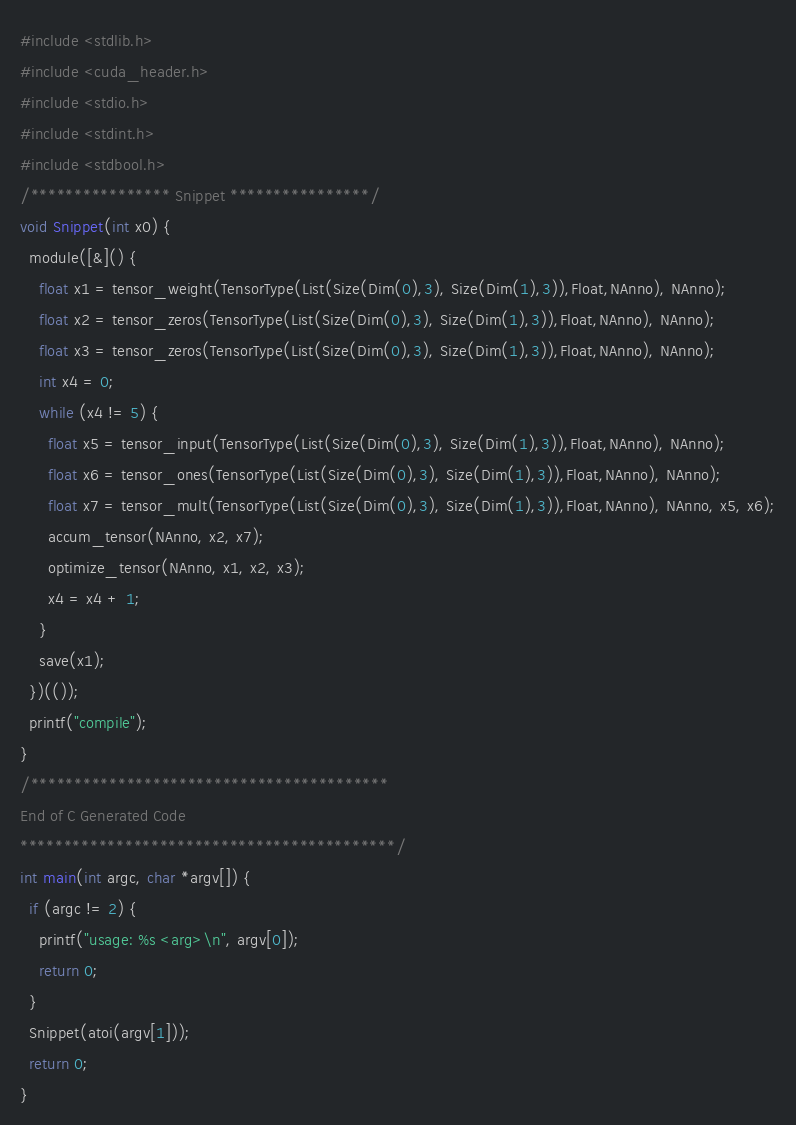<code> <loc_0><loc_0><loc_500><loc_500><_Cuda_>#include <stdlib.h>
#include <cuda_header.h>
#include <stdio.h>
#include <stdint.h>
#include <stdbool.h>
/**************** Snippet ****************/
void Snippet(int x0) {
  module([&]() {
    float x1 = tensor_weight(TensorType(List(Size(Dim(0),3), Size(Dim(1),3)),Float,NAnno), NAnno);
    float x2 = tensor_zeros(TensorType(List(Size(Dim(0),3), Size(Dim(1),3)),Float,NAnno), NAnno);
    float x3 = tensor_zeros(TensorType(List(Size(Dim(0),3), Size(Dim(1),3)),Float,NAnno), NAnno);
    int x4 = 0;
    while (x4 != 5) {
      float x5 = tensor_input(TensorType(List(Size(Dim(0),3), Size(Dim(1),3)),Float,NAnno), NAnno);
      float x6 = tensor_ones(TensorType(List(Size(Dim(0),3), Size(Dim(1),3)),Float,NAnno), NAnno);
      float x7 = tensor_mult(TensorType(List(Size(Dim(0),3), Size(Dim(1),3)),Float,NAnno), NAnno, x5, x6);
      accum_tensor(NAnno, x2, x7);
      optimize_tensor(NAnno, x1, x2, x3);
      x4 = x4 + 1;
    }
    save(x1);
  })(());
  printf("compile");
}
/*****************************************
End of C Generated Code
*******************************************/
int main(int argc, char *argv[]) {
  if (argc != 2) {
    printf("usage: %s <arg>\n", argv[0]);
    return 0;
  }
  Snippet(atoi(argv[1]));
  return 0;
}
</code> 